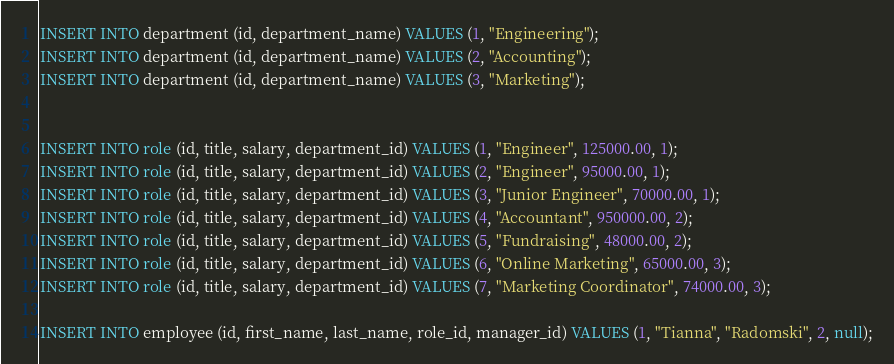<code> <loc_0><loc_0><loc_500><loc_500><_SQL_>INSERT INTO department (id, department_name) VALUES (1, "Engineering");
INSERT INTO department (id, department_name) VALUES (2, "Accounting");
INSERT INTO department (id, department_name) VALUES (3, "Marketing");


INSERT INTO role (id, title, salary, department_id) VALUES (1, "Engineer", 125000.00, 1);
INSERT INTO role (id, title, salary, department_id) VALUES (2, "Engineer", 95000.00, 1);
INSERT INTO role (id, title, salary, department_id) VALUES (3, "Junior Engineer", 70000.00, 1);
INSERT INTO role (id, title, salary, department_id) VALUES (4, "Accountant", 950000.00, 2);
INSERT INTO role (id, title, salary, department_id) VALUES (5, "Fundraising", 48000.00, 2);
INSERT INTO role (id, title, salary, department_id) VALUES (6, "Online Marketing", 65000.00, 3);
INSERT INTO role (id, title, salary, department_id) VALUES (7, "Marketing Coordinator", 74000.00, 3);

INSERT INTO employee (id, first_name, last_name, role_id, manager_id) VALUES (1, "Tianna", "Radomski", 2, null);</code> 